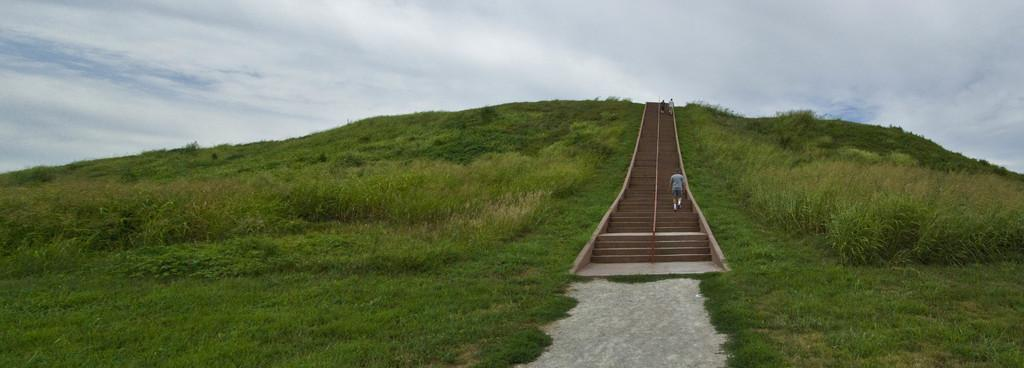What type of vegetation is present in the image? There is green grass in the image. What architectural feature can be seen in the image? There are stairs in the image. What are the people in the image doing? The people are standing on the stairs. What can be seen in the background of the image? There are clouds and the sky visible in the background of the image. What type of metal is used to make the horseshoes in the image? There are no horses or horseshoes present in the image, so it is not possible to determine the type of metal used. 